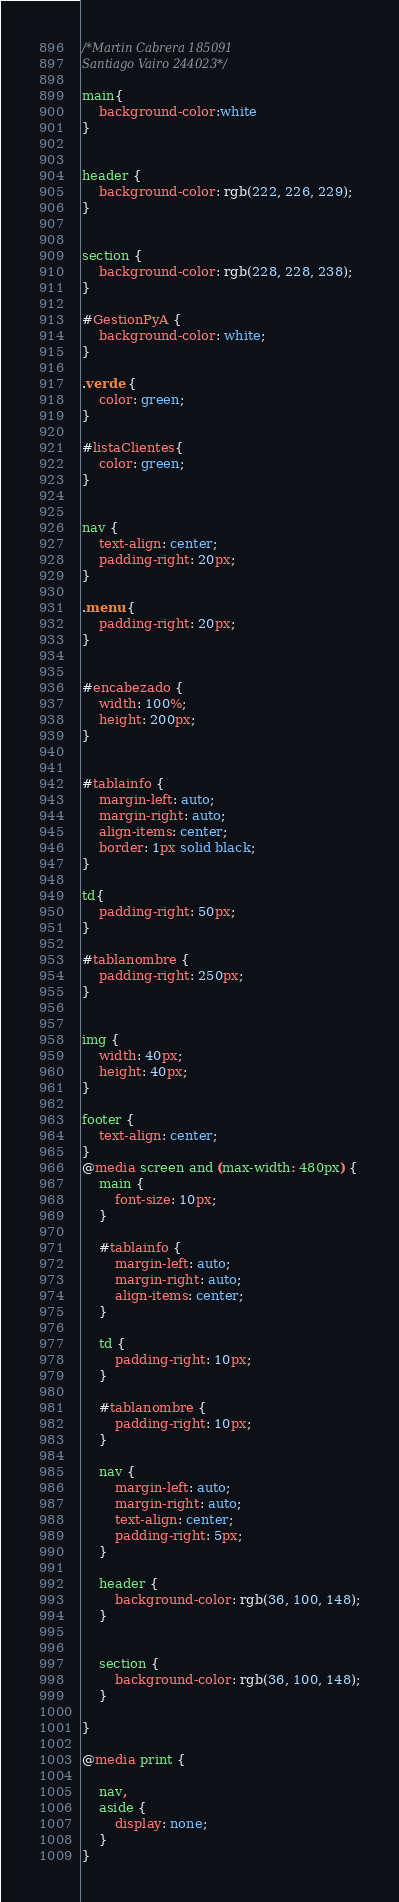<code> <loc_0><loc_0><loc_500><loc_500><_CSS_>/*Martin Cabrera 185091
Santiago Vairo 244023*/

main{
    background-color:white
}


header {
    background-color: rgb(222, 226, 229);
}


section {
    background-color: rgb(228, 228, 238);
}

#GestionPyA {
    background-color: white;
}

.verde {
    color: green;
}

#listaClientes{
    color: green;
}


nav {
    text-align: center;
    padding-right: 20px;
}

.menu {
    padding-right: 20px;
}


#encabezado {
    width: 100%;
    height: 200px;
}


#tablainfo {
    margin-left: auto;
    margin-right: auto;
    align-items: center;
    border: 1px solid black;
}

td{
    padding-right: 50px;
}

#tablanombre {
    padding-right: 250px;
}


img {
    width: 40px;
    height: 40px;
}

footer {
    text-align: center;
}
@media screen and (max-width: 480px) {
    main {
        font-size: 10px;
    }

    #tablainfo {
        margin-left: auto;
        margin-right: auto;
        align-items: center;
    }

    td {
        padding-right: 10px;
    }

    #tablanombre {
        padding-right: 10px;
    }

    nav {
        margin-left: auto;
        margin-right: auto;
        text-align: center;
        padding-right: 5px;
    }

    header {
        background-color: rgb(36, 100, 148);
    }


    section {
        background-color: rgb(36, 100, 148);
    }

}

@media print {

    nav,
    aside {
        display: none;
    }
}</code> 